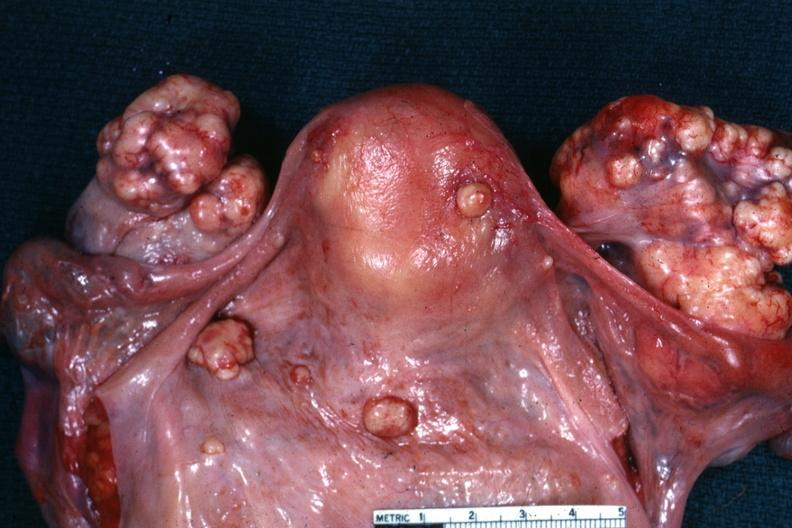s this true bilateral krukenberg?
Answer the question using a single word or phrase. Yes 